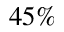Convert formula to latex. <formula><loc_0><loc_0><loc_500><loc_500>4 5 \%</formula> 